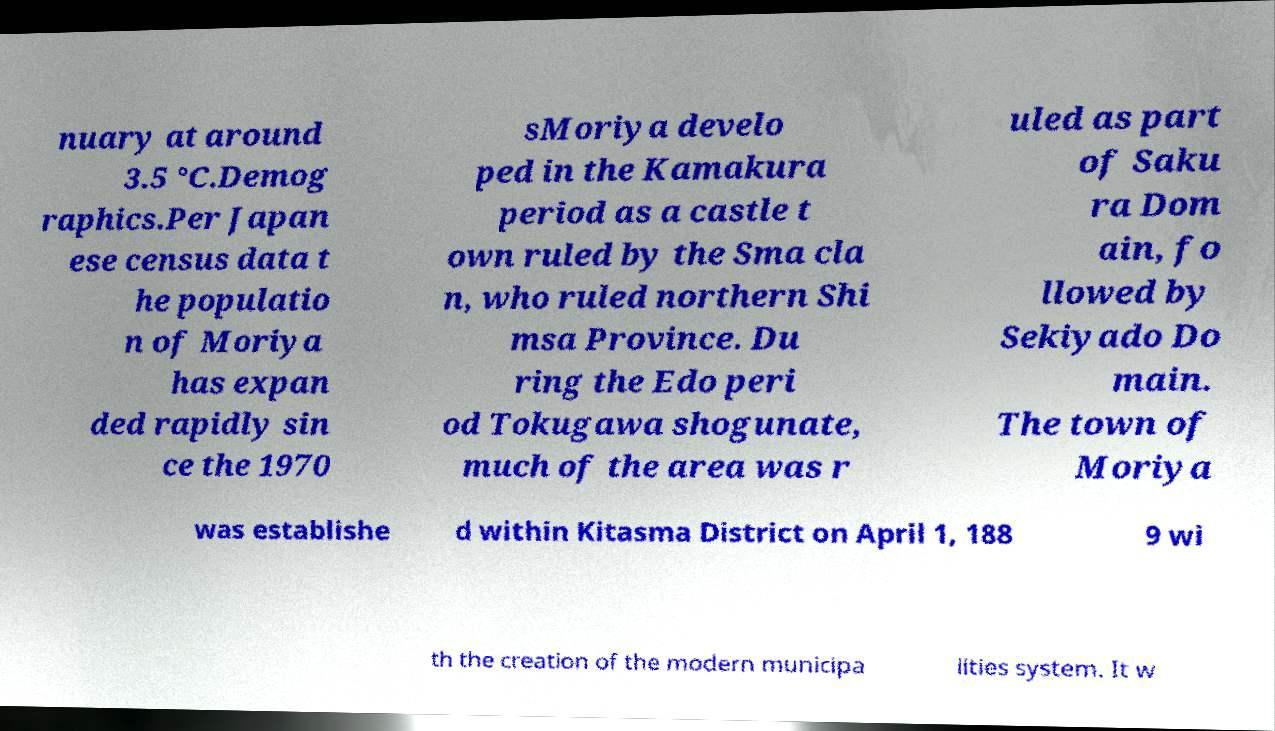Could you assist in decoding the text presented in this image and type it out clearly? nuary at around 3.5 °C.Demog raphics.Per Japan ese census data t he populatio n of Moriya has expan ded rapidly sin ce the 1970 sMoriya develo ped in the Kamakura period as a castle t own ruled by the Sma cla n, who ruled northern Shi msa Province. Du ring the Edo peri od Tokugawa shogunate, much of the area was r uled as part of Saku ra Dom ain, fo llowed by Sekiyado Do main. The town of Moriya was establishe d within Kitasma District on April 1, 188 9 wi th the creation of the modern municipa lities system. It w 